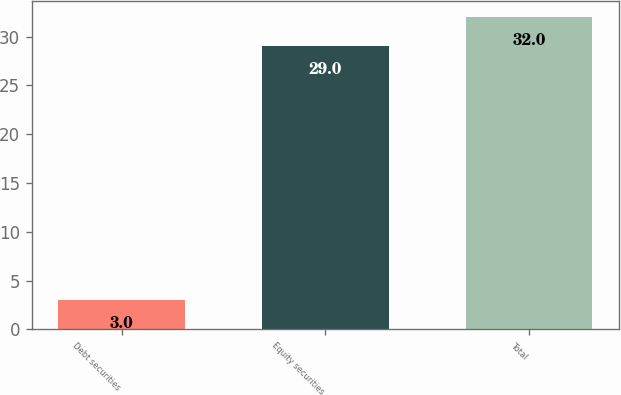Convert chart. <chart><loc_0><loc_0><loc_500><loc_500><bar_chart><fcel>Debt securities<fcel>Equity securities<fcel>Total<nl><fcel>3<fcel>29<fcel>32<nl></chart> 